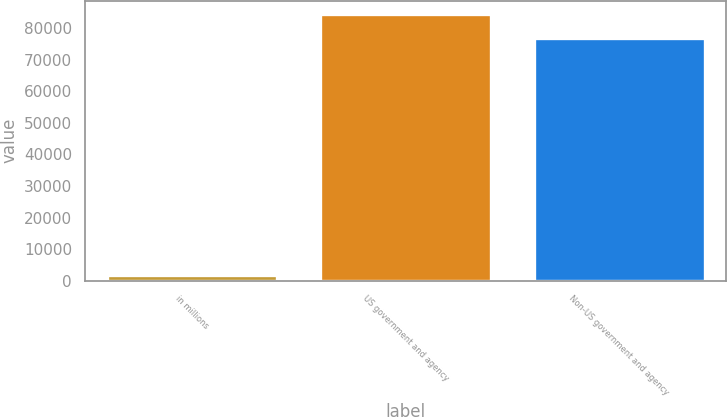Convert chart. <chart><loc_0><loc_0><loc_500><loc_500><bar_chart><fcel>in millions<fcel>US government and agency<fcel>Non-US government and agency<nl><fcel>2018<fcel>84426<fcel>76745<nl></chart> 